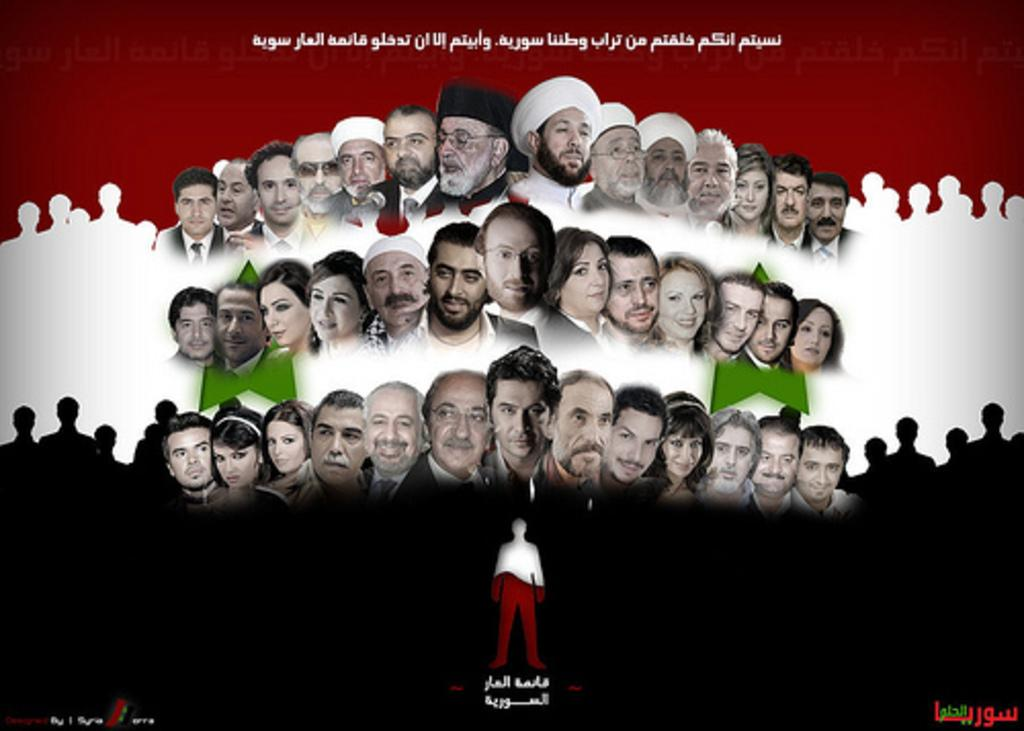What type of visual element is present in the image? The image contains a graphical element. Can you describe the people in the image? There are people in the image, but their specific characteristics are not mentioned in the facts. What else can be found in the image besides the graphical element and people? There is text present in the image. What type of wall is visible in the image? There is no mention of a wall in the provided facts, so it cannot be determined if a wall is present in the image. 